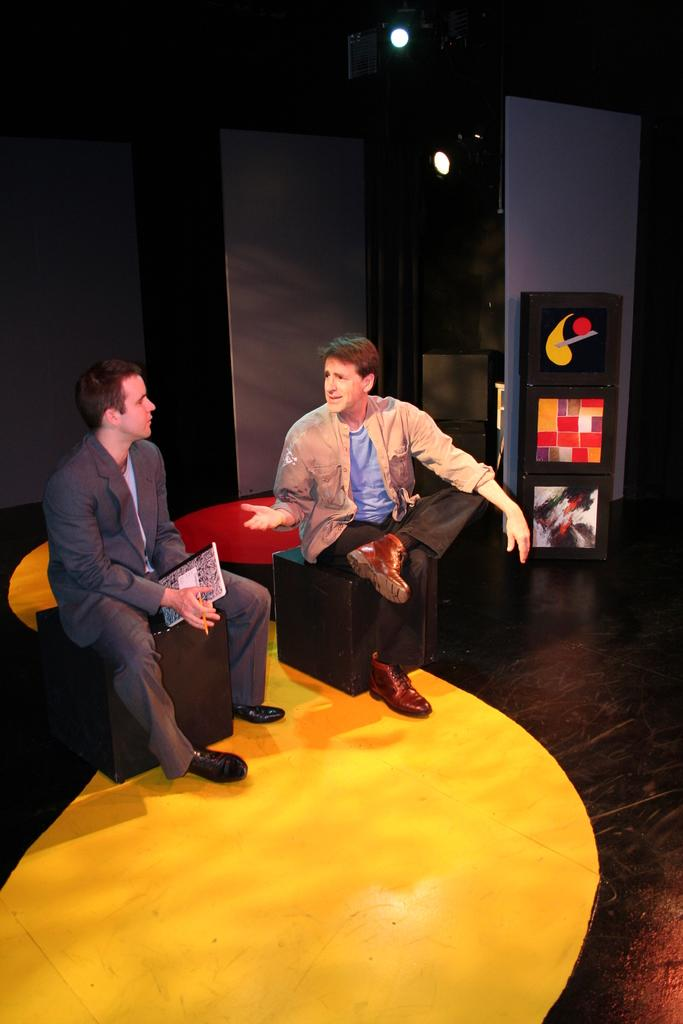How many people are in the image? There are two men in the image. What are the men doing in the image? The men are sitting on stools. Where are the stools located in the image? The stools are in the middle of the image. What can be seen in the background of the image? There is a wall in the background of the image. What type of copper material is present in the image? There is no copper material present in the image. How quiet are the men in the image? The image does not provide information about the volume or noise level of the men, so we cannot determine how quiet they are. 